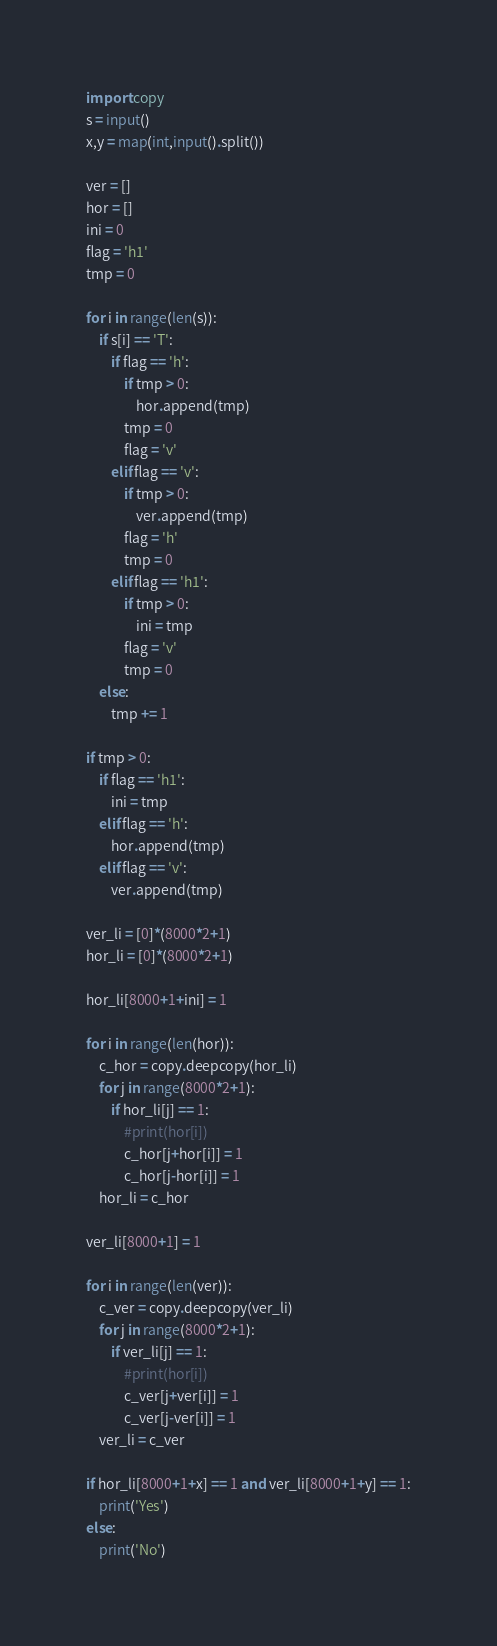Convert code to text. <code><loc_0><loc_0><loc_500><loc_500><_Python_>import copy
s = input()
x,y = map(int,input().split())

ver = []
hor = []
ini = 0
flag = 'h1'
tmp = 0

for i in range(len(s)):
    if s[i] == 'T':
        if flag == 'h':
            if tmp > 0:
                hor.append(tmp)
            tmp = 0
            flag = 'v'
        elif flag == 'v':
            if tmp > 0:
                ver.append(tmp)
            flag = 'h'
            tmp = 0
        elif flag == 'h1':
            if tmp > 0:
                ini = tmp
            flag = 'v'
            tmp = 0
    else:
        tmp += 1

if tmp > 0:
    if flag == 'h1':
        ini = tmp
    elif flag == 'h':
        hor.append(tmp)
    elif flag == 'v':
        ver.append(tmp)
        
ver_li = [0]*(8000*2+1)
hor_li = [0]*(8000*2+1)

hor_li[8000+1+ini] = 1

for i in range(len(hor)):
    c_hor = copy.deepcopy(hor_li)
    for j in range(8000*2+1):
        if hor_li[j] == 1:
            #print(hor[i])
            c_hor[j+hor[i]] = 1
            c_hor[j-hor[i]] = 1
    hor_li = c_hor

ver_li[8000+1] = 1

for i in range(len(ver)):
    c_ver = copy.deepcopy(ver_li)
    for j in range(8000*2+1):
        if ver_li[j] == 1:
            #print(hor[i])
            c_ver[j+ver[i]] = 1
            c_ver[j-ver[i]] = 1
    ver_li = c_ver
    
if hor_li[8000+1+x] == 1 and ver_li[8000+1+y] == 1:
    print('Yes')
else:
    print('No')</code> 